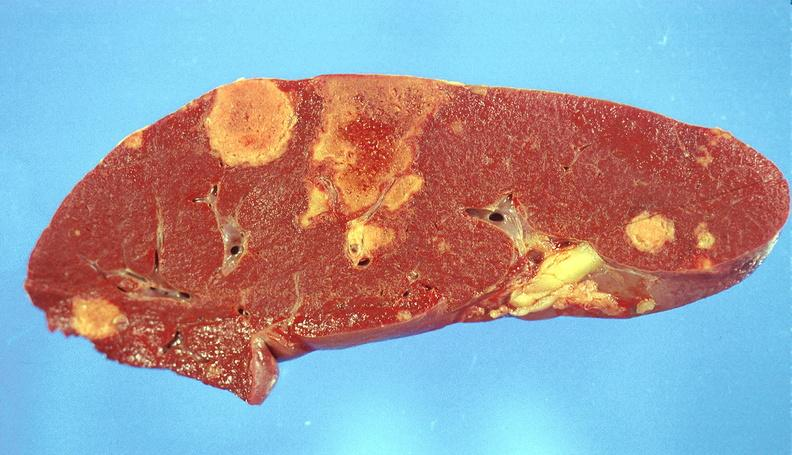s hematologic present?
Answer the question using a single word or phrase. Yes 